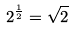Convert formula to latex. <formula><loc_0><loc_0><loc_500><loc_500>2 ^ { \frac { 1 } { 2 } } = \sqrt { 2 }</formula> 